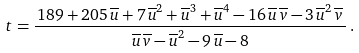Convert formula to latex. <formula><loc_0><loc_0><loc_500><loc_500>t = \frac { \, 1 8 9 + 2 0 5 \, \overline { u } + 7 \, \overline { u } ^ { 2 } + \overline { u } ^ { 3 } + \overline { u } ^ { 4 } - 1 6 \, \overline { u } \, \overline { v } - 3 \, \overline { u } ^ { 2 } \, \overline { v } \, } { \, \overline { u } \, \overline { v } - \overline { u } ^ { 2 } - 9 \, \overline { u } - 8 \, } \, .</formula> 